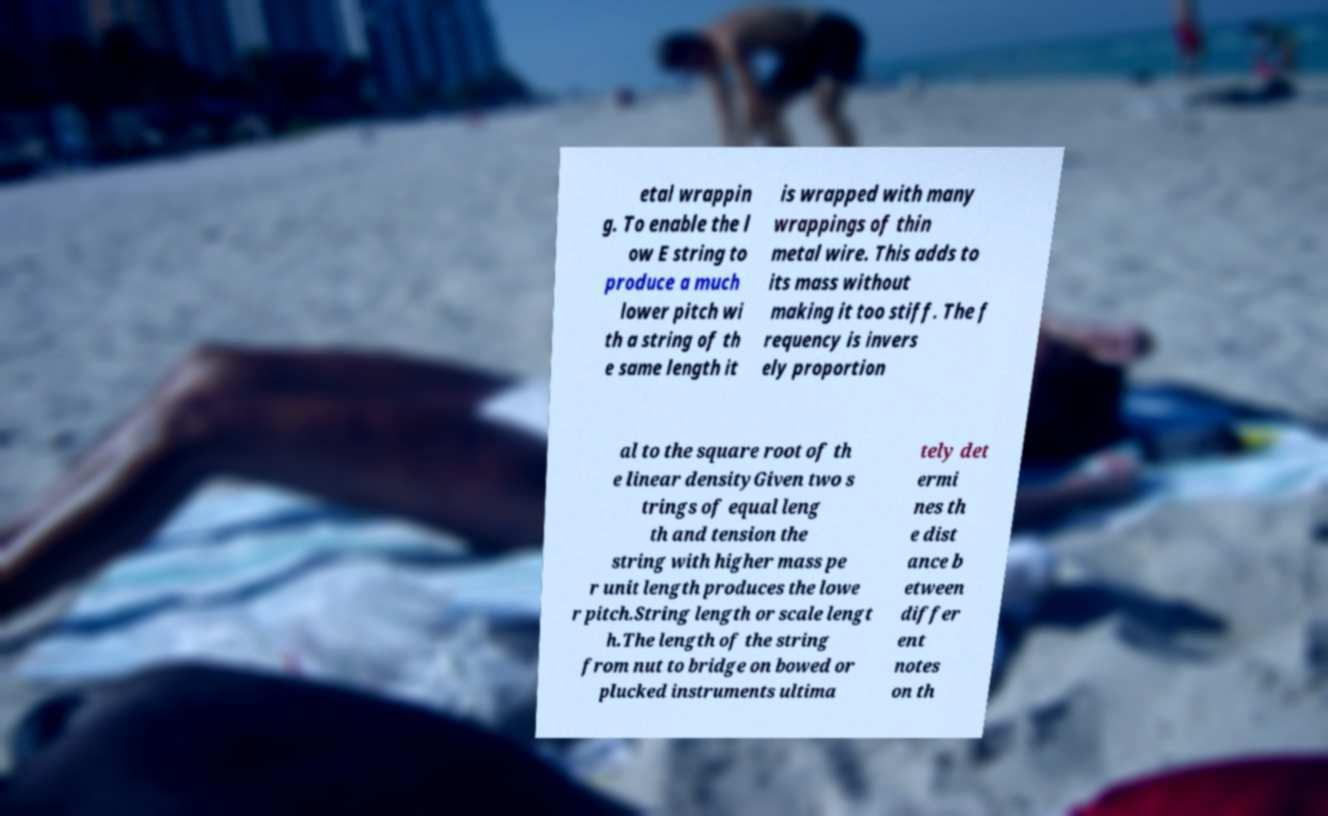Could you assist in decoding the text presented in this image and type it out clearly? etal wrappin g. To enable the l ow E string to produce a much lower pitch wi th a string of th e same length it is wrapped with many wrappings of thin metal wire. This adds to its mass without making it too stiff. The f requency is invers ely proportion al to the square root of th e linear densityGiven two s trings of equal leng th and tension the string with higher mass pe r unit length produces the lowe r pitch.String length or scale lengt h.The length of the string from nut to bridge on bowed or plucked instruments ultima tely det ermi nes th e dist ance b etween differ ent notes on th 